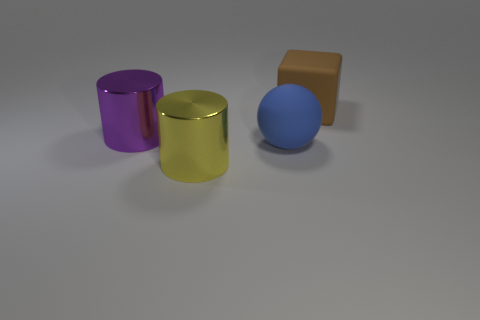Add 1 purple objects. How many objects exist? 5 Subtract all balls. How many objects are left? 3 Add 2 large matte balls. How many large matte balls exist? 3 Subtract 0 purple blocks. How many objects are left? 4 Subtract all large purple matte cylinders. Subtract all large yellow metal objects. How many objects are left? 3 Add 3 large matte blocks. How many large matte blocks are left? 4 